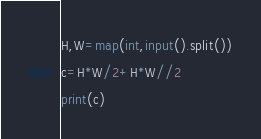<code> <loc_0><loc_0><loc_500><loc_500><_Python_>H,W=map(int,input().split())
c=H*W/2+H*W//2
print(c)
</code> 